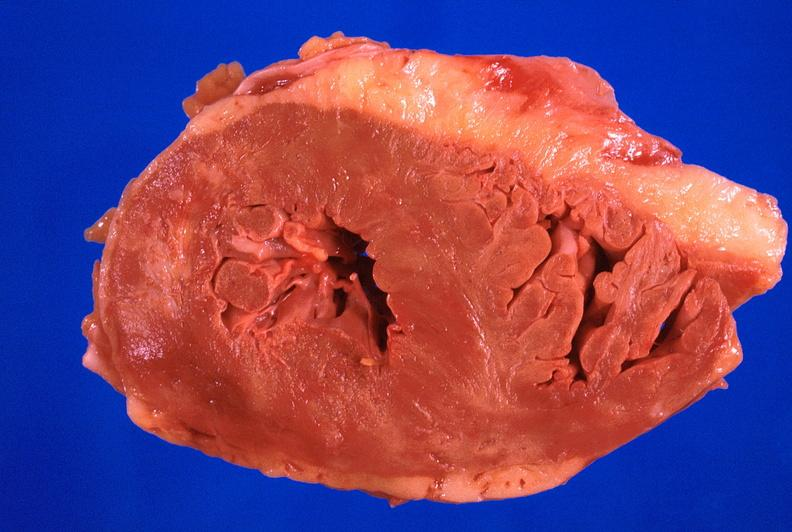what does this image show?
Answer the question using a single word or phrase. Heart 